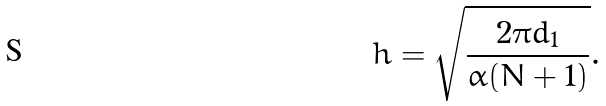<formula> <loc_0><loc_0><loc_500><loc_500>h = \sqrt { \frac { 2 \pi d _ { 1 } } { \alpha ( N + 1 ) } } .</formula> 